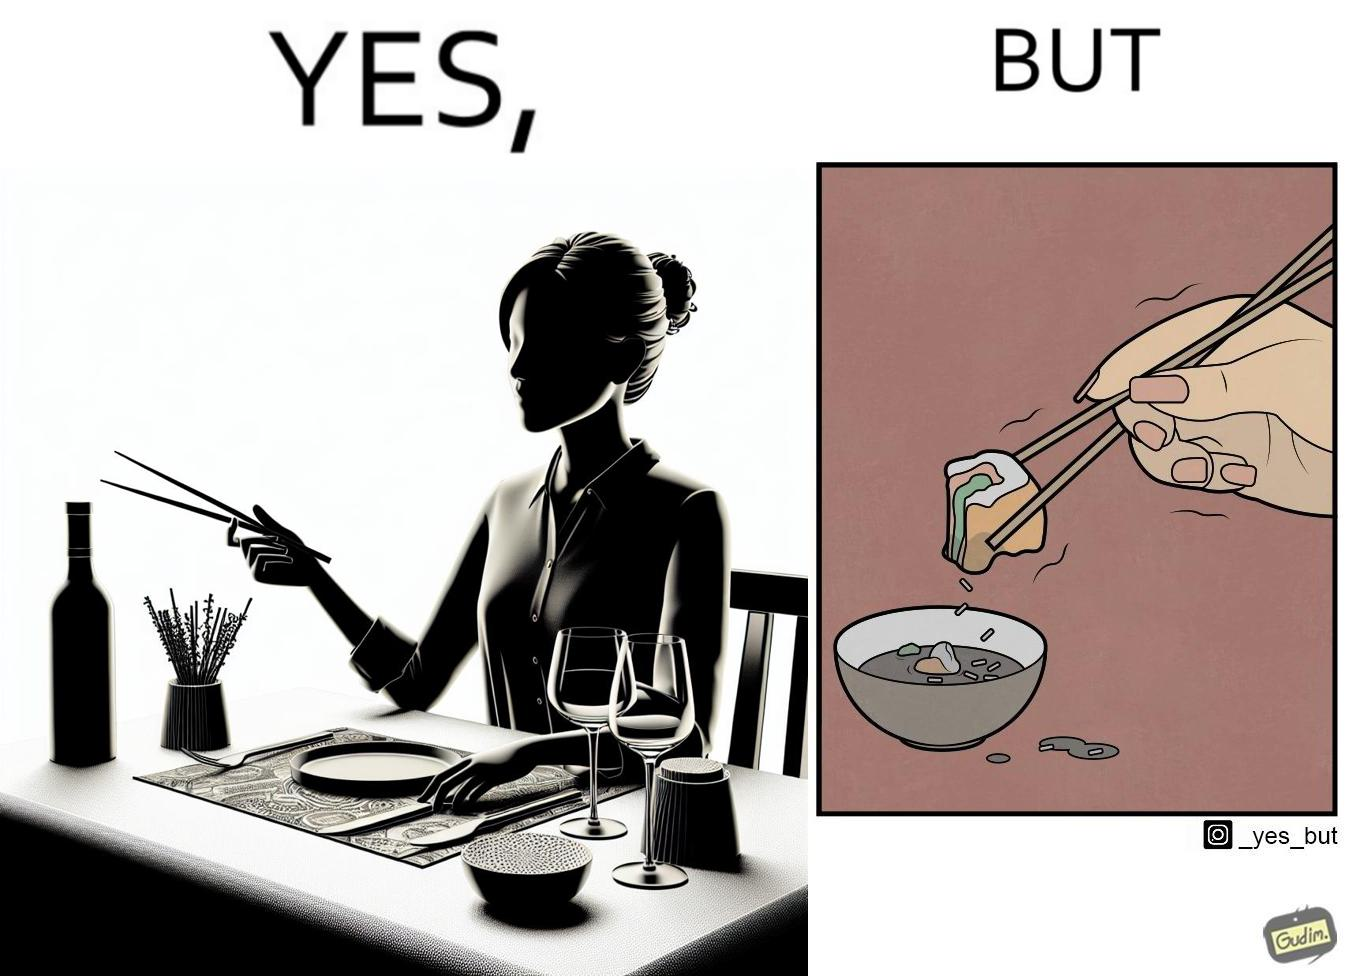Does this image contain satire or humor? Yes, this image is satirical. 